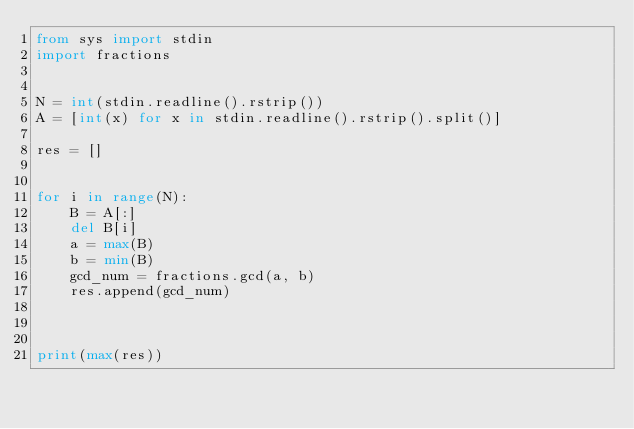<code> <loc_0><loc_0><loc_500><loc_500><_Python_>from sys import stdin
import fractions


N = int(stdin.readline().rstrip())
A = [int(x) for x in stdin.readline().rstrip().split()]

res = []


for i in range(N):
    B = A[:]
    del B[i]
    a = max(B)
    b = min(B)
    gcd_num = fractions.gcd(a, b)
    res.append(gcd_num)
        


print(max(res))
</code> 